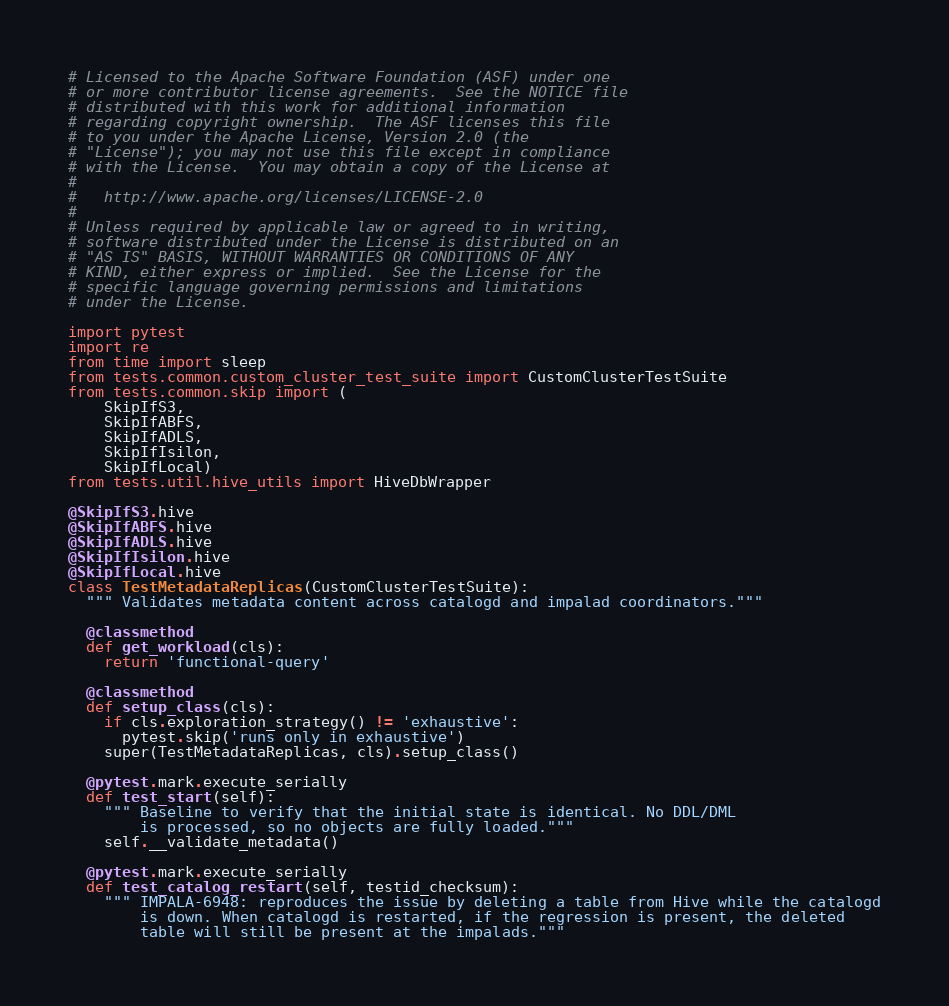<code> <loc_0><loc_0><loc_500><loc_500><_Python_># Licensed to the Apache Software Foundation (ASF) under one
# or more contributor license agreements.  See the NOTICE file
# distributed with this work for additional information
# regarding copyright ownership.  The ASF licenses this file
# to you under the Apache License, Version 2.0 (the
# "License"); you may not use this file except in compliance
# with the License.  You may obtain a copy of the License at
#
#   http://www.apache.org/licenses/LICENSE-2.0
#
# Unless required by applicable law or agreed to in writing,
# software distributed under the License is distributed on an
# "AS IS" BASIS, WITHOUT WARRANTIES OR CONDITIONS OF ANY
# KIND, either express or implied.  See the License for the
# specific language governing permissions and limitations
# under the License.

import pytest
import re
from time import sleep
from tests.common.custom_cluster_test_suite import CustomClusterTestSuite
from tests.common.skip import (
    SkipIfS3,
    SkipIfABFS,
    SkipIfADLS,
    SkipIfIsilon,
    SkipIfLocal)
from tests.util.hive_utils import HiveDbWrapper

@SkipIfS3.hive
@SkipIfABFS.hive
@SkipIfADLS.hive
@SkipIfIsilon.hive
@SkipIfLocal.hive
class TestMetadataReplicas(CustomClusterTestSuite):
  """ Validates metadata content across catalogd and impalad coordinators."""

  @classmethod
  def get_workload(cls):
    return 'functional-query'

  @classmethod
  def setup_class(cls):
    if cls.exploration_strategy() != 'exhaustive':
      pytest.skip('runs only in exhaustive')
    super(TestMetadataReplicas, cls).setup_class()

  @pytest.mark.execute_serially
  def test_start(self):
    """ Baseline to verify that the initial state is identical. No DDL/DML
        is processed, so no objects are fully loaded."""
    self.__validate_metadata()

  @pytest.mark.execute_serially
  def test_catalog_restart(self, testid_checksum):
    """ IMPALA-6948: reproduces the issue by deleting a table from Hive while the catalogd
        is down. When catalogd is restarted, if the regression is present, the deleted
        table will still be present at the impalads."""</code> 